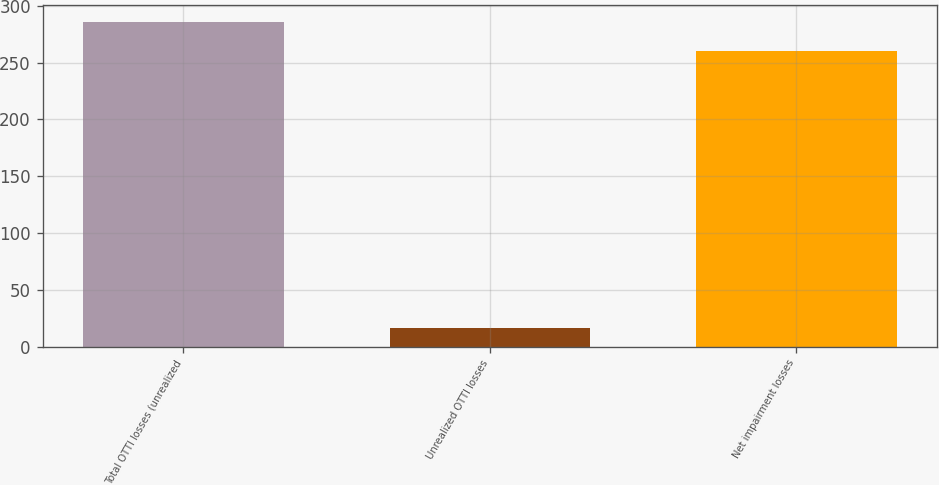Convert chart. <chart><loc_0><loc_0><loc_500><loc_500><bar_chart><fcel>Total OTTI losses (unrealized<fcel>Unrealized OTTI losses<fcel>Net impairment losses<nl><fcel>286<fcel>16<fcel>260<nl></chart> 